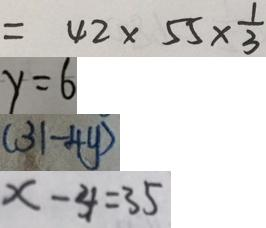Convert formula to latex. <formula><loc_0><loc_0><loc_500><loc_500>= 4 2 \times 5 5 \times \frac { 1 } { 3 } 
 y = 6 
 ( 3 1 - 4 y ) 
 x - 4 = 3 5</formula> 